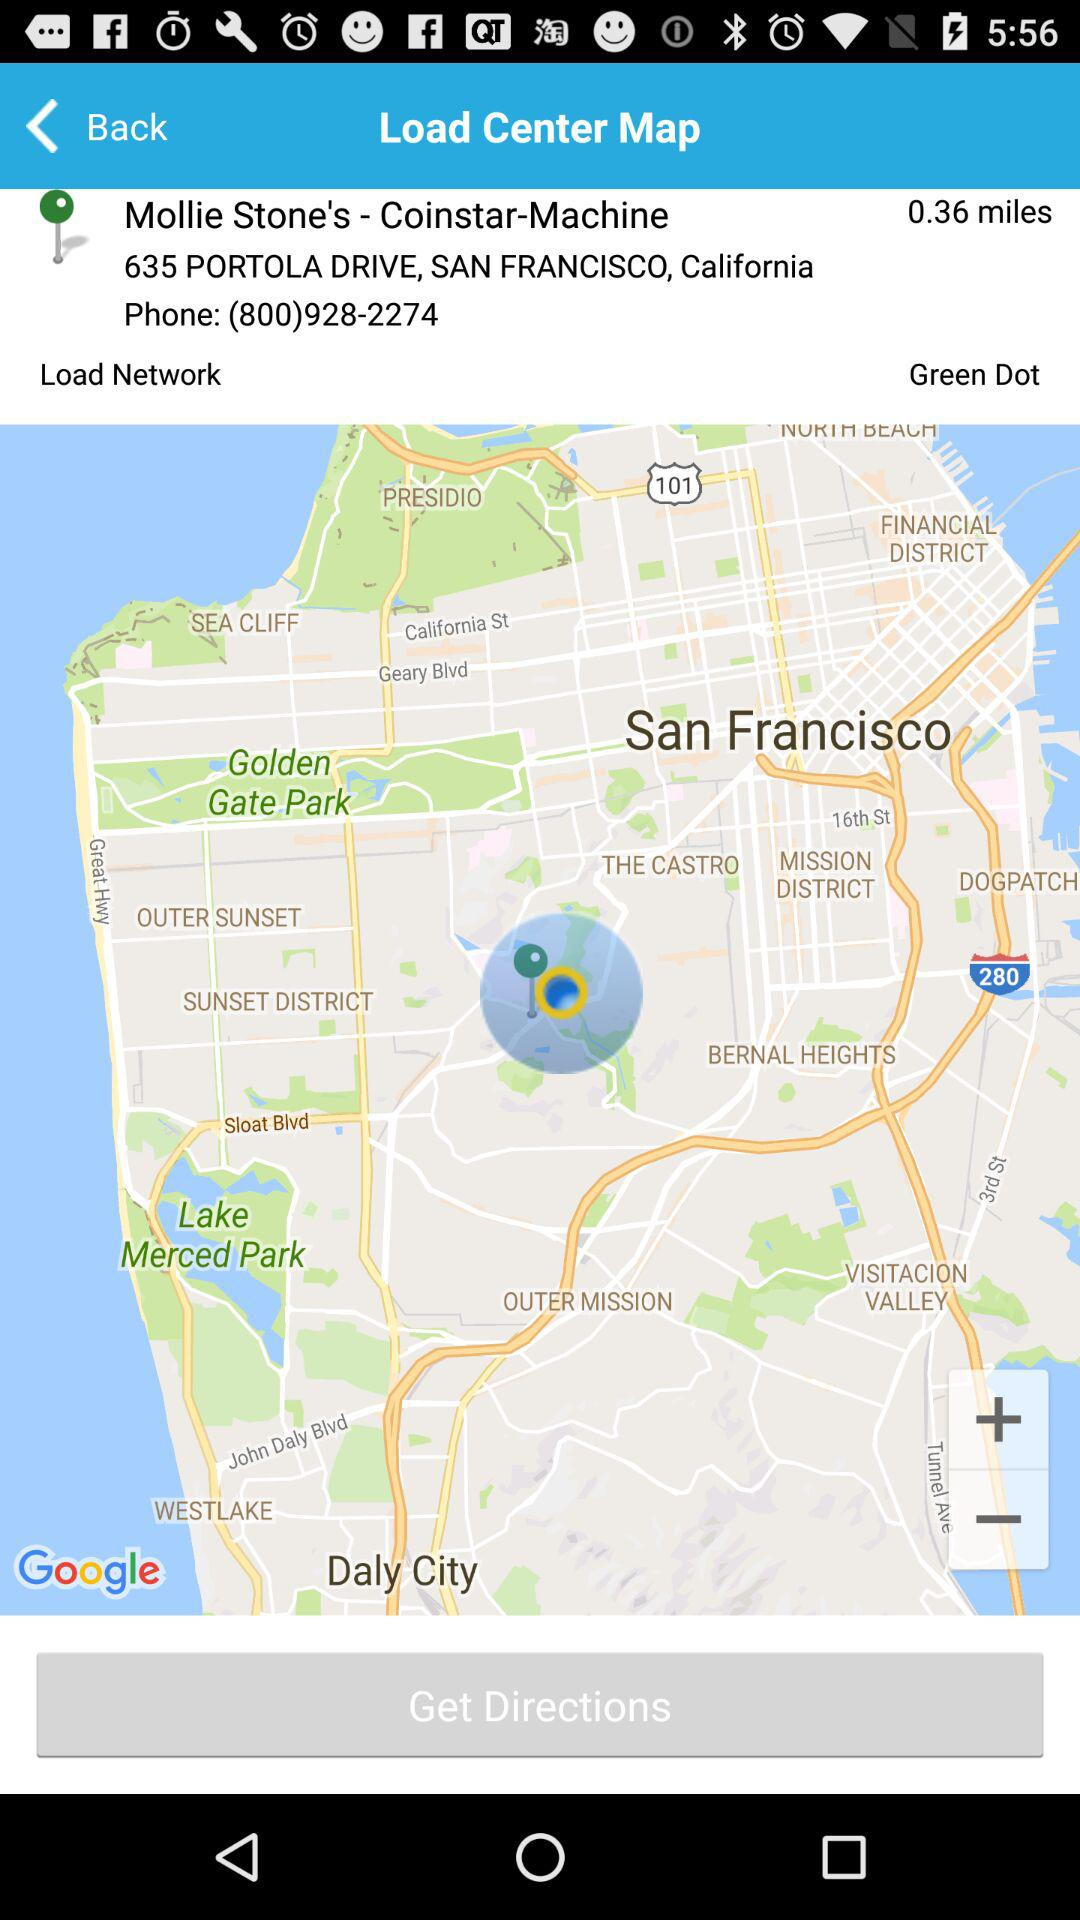What is the user's address?
When the provided information is insufficient, respond with <no answer>. <no answer> 